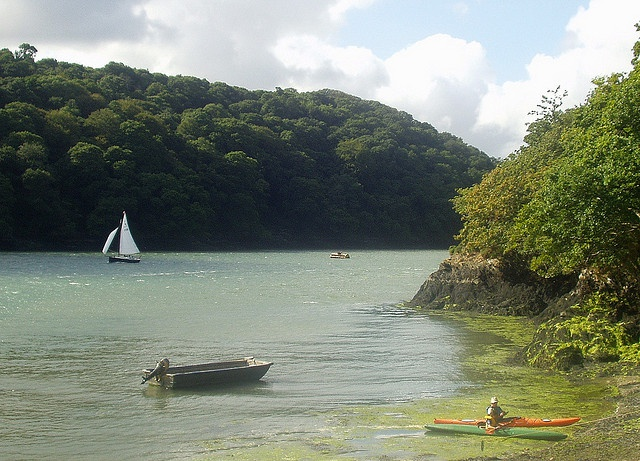Describe the objects in this image and their specific colors. I can see boat in lightgray, black, gray, and darkgray tones, boat in lightgray, olive, brown, and tan tones, boat in lightgray, darkgray, black, and gray tones, people in lightgray, olive, gray, and beige tones, and boat in lightgray, ivory, gray, tan, and black tones in this image. 